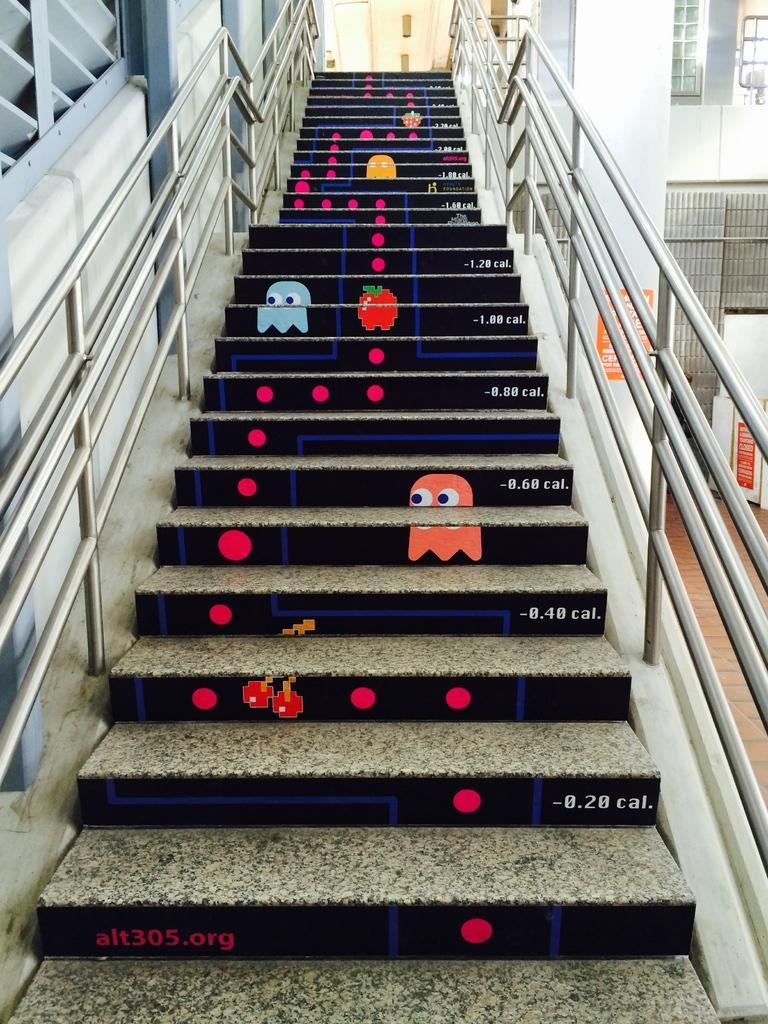Could you give a brief overview of what you see in this image? There are steps with railings. On the steps there are some paintings of cartoons and circles. On the right side there is a building with windows. 